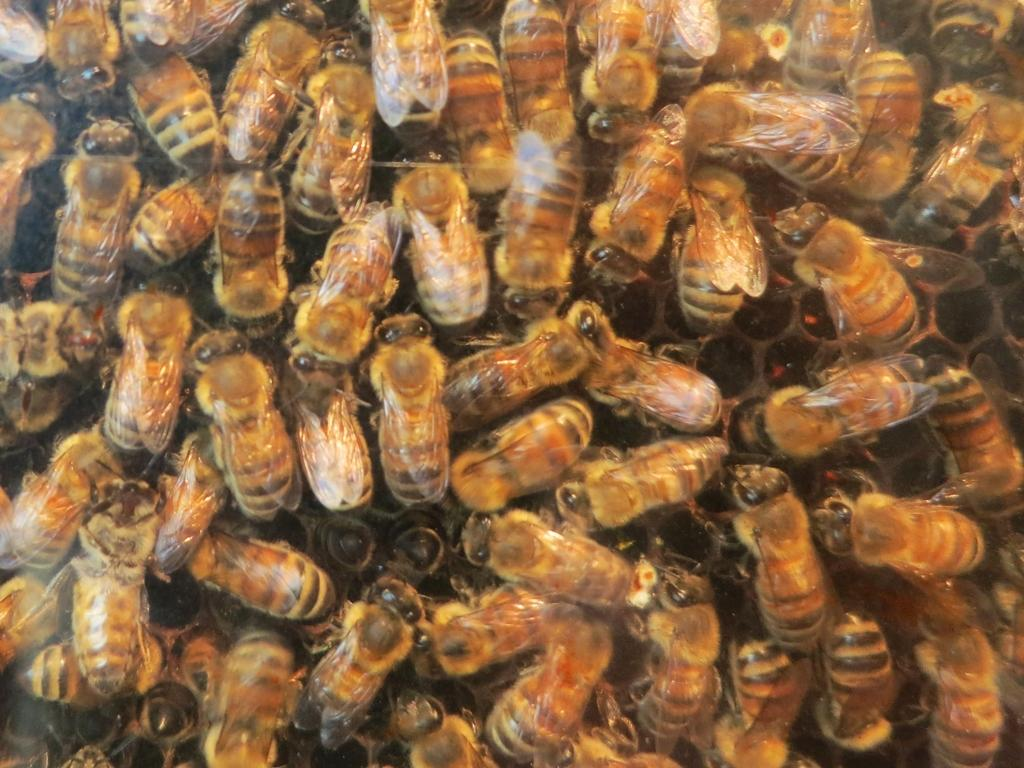What type of insects are present in the image? There is a group of honey bees in the image. Where are the honey bees located? The honey bees are on a honeycomb. What type of maid can be seen cleaning the honeycomb in the image? There is no maid present in the image; it features a group of honey bees on a honeycomb. 